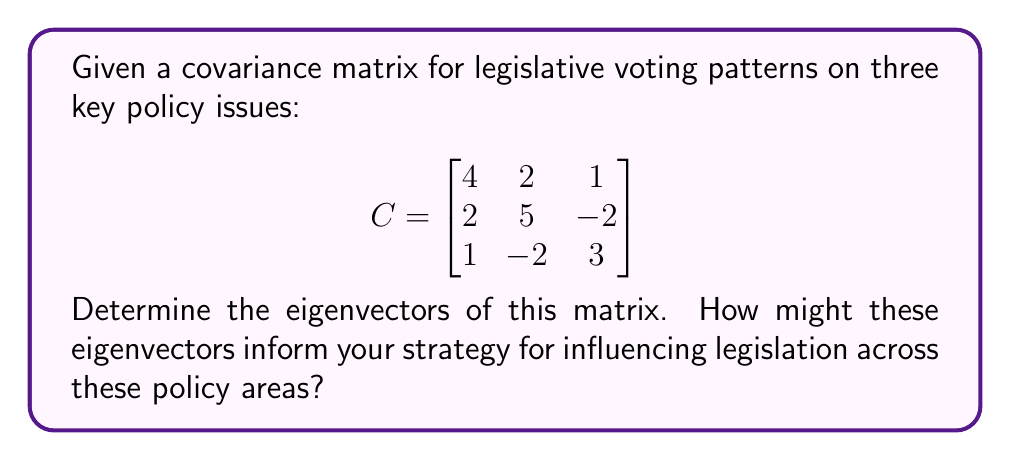Teach me how to tackle this problem. To find the eigenvectors of the covariance matrix C, we follow these steps:

1) First, we need to find the eigenvalues by solving the characteristic equation:
   $\det(C - \lambda I) = 0$

2) Expanding this determinant:
   $$\begin{vmatrix}
   4-\lambda & 2 & 1 \\
   2 & 5-\lambda & -2 \\
   1 & -2 & 3-\lambda
   \end{vmatrix} = 0$$

3) This gives us the characteristic polynomial:
   $-\lambda^3 + 12\lambda^2 - 41\lambda + 40 = 0$

4) Solving this equation (using a computer algebra system or factoring), we get:
   $\lambda_1 = 1$, $\lambda_2 = 3$, $\lambda_3 = 8$

5) For each eigenvalue, we solve $(C - \lambda I)v = 0$ to find the corresponding eigenvector:

   For $\lambda_1 = 1$:
   $$\begin{bmatrix}
   3 & 2 & 1 \\
   2 & 4 & -2 \\
   1 & -2 & 2
   \end{bmatrix} \begin{bmatrix} v_1 \\ v_2 \\ v_3 \end{bmatrix} = \begin{bmatrix} 0 \\ 0 \\ 0 \end{bmatrix}$$
   Solving this gives us: $v_1 = [-1, 0, 1]^T$

   For $\lambda_2 = 3$:
   $$\begin{bmatrix}
   1 & 2 & 1 \\
   2 & 2 & -2 \\
   1 & -2 & 0
   \end{bmatrix} \begin{bmatrix} v_1 \\ v_2 \\ v_3 \end{bmatrix} = \begin{bmatrix} 0 \\ 0 \\ 0 \end{bmatrix}$$
   Solving this gives us: $v_2 = [1, -1, 1]^T$

   For $\lambda_3 = 8$:
   $$\begin{bmatrix}
   -4 & 2 & 1 \\
   2 & -3 & -2 \\
   1 & -2 & -5
   \end{bmatrix} \begin{bmatrix} v_1 \\ v_2 \\ v_3 \end{bmatrix} = \begin{bmatrix} 0 \\ 0 \\ 0 \end{bmatrix}$$
   Solving this gives us: $v_3 = [2, 2, 1]^T$

6) Normalizing these eigenvectors, we get:
   $v_1 = [-\frac{1}{\sqrt{2}}, 0, \frac{1}{\sqrt{2}}]^T$
   $v_2 = [\frac{1}{\sqrt{3}}, -\frac{1}{\sqrt{3}}, \frac{1}{\sqrt{3}}]^T$
   $v_3 = [\frac{2}{\sqrt{9}}, \frac{2}{\sqrt{9}}, \frac{1}{\sqrt{9}}]^T$

These eigenvectors represent the principal components of variation in legislative voting patterns. The eigenvector with the largest eigenvalue (v3) indicates the direction of maximum variance, suggesting the most influential combination of policy issues.
Answer: $v_1 = [-\frac{1}{\sqrt{2}}, 0, \frac{1}{\sqrt{2}}]^T$, $v_2 = [\frac{1}{\sqrt{3}}, -\frac{1}{\sqrt{3}}, \frac{1}{\sqrt{3}}]^T$, $v_3 = [\frac{2}{\sqrt{9}}, \frac{2}{\sqrt{9}}, \frac{1}{\sqrt{9}}]^T$ 